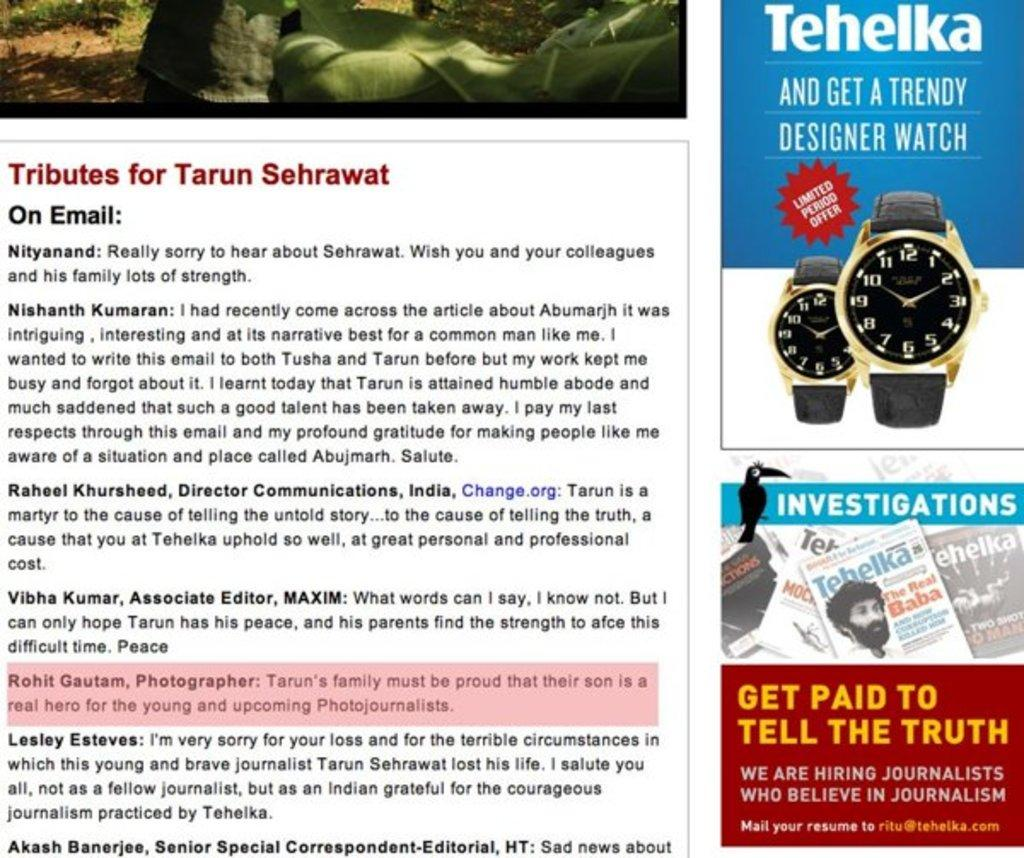Provide a one-sentence caption for the provided image. An advertisement for a watch made by the bran Tehelka. 